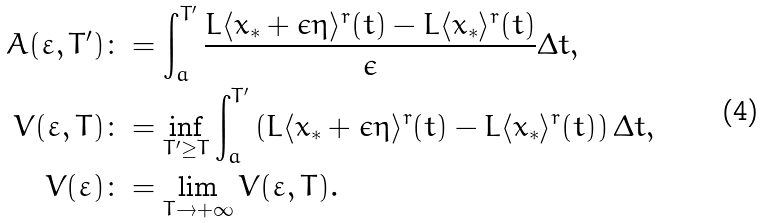Convert formula to latex. <formula><loc_0><loc_0><loc_500><loc_500>A ( \varepsilon , T ^ { \prime } ) & \colon = \int _ { a } ^ { T ^ { \prime } } \frac { L \langle x _ { \ast } + \epsilon \eta \rangle ^ { r } ( t ) - L \langle x _ { \ast } \rangle ^ { r } ( t ) } { \epsilon } \Delta t , \\ V ( \varepsilon , T ) & \colon = \inf _ { T ^ { \prime } \geq T } \int _ { a } ^ { T ^ { \prime } } \left ( L \langle x _ { \ast } + \epsilon \eta \rangle ^ { r } ( t ) - L \langle x _ { \ast } \rangle ^ { r } ( t ) \right ) \Delta t , \\ V ( \varepsilon ) & \colon = \lim _ { T \rightarrow + \infty } V ( \varepsilon , T ) .</formula> 